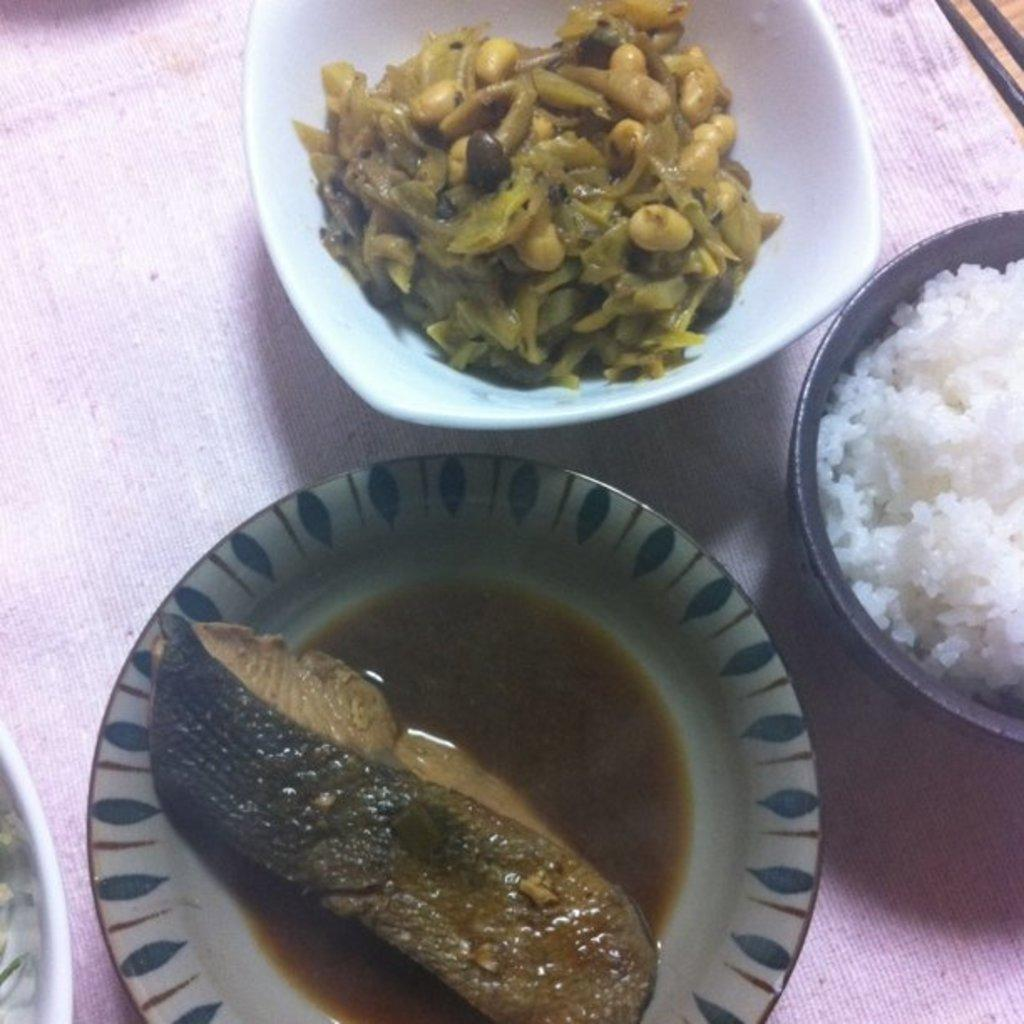How many bowls with food items are visible in the image? There are three bowls with food items in the image. What else can be seen in the image besides the bowls? There is a cloth in the image. Can you describe the color of the cloth? The cloth is light pink in color. What language is spoken by the rice in the image? There is no rice or language spoken in the image. The image only shows three bowls with food items and a light pink cloth. 